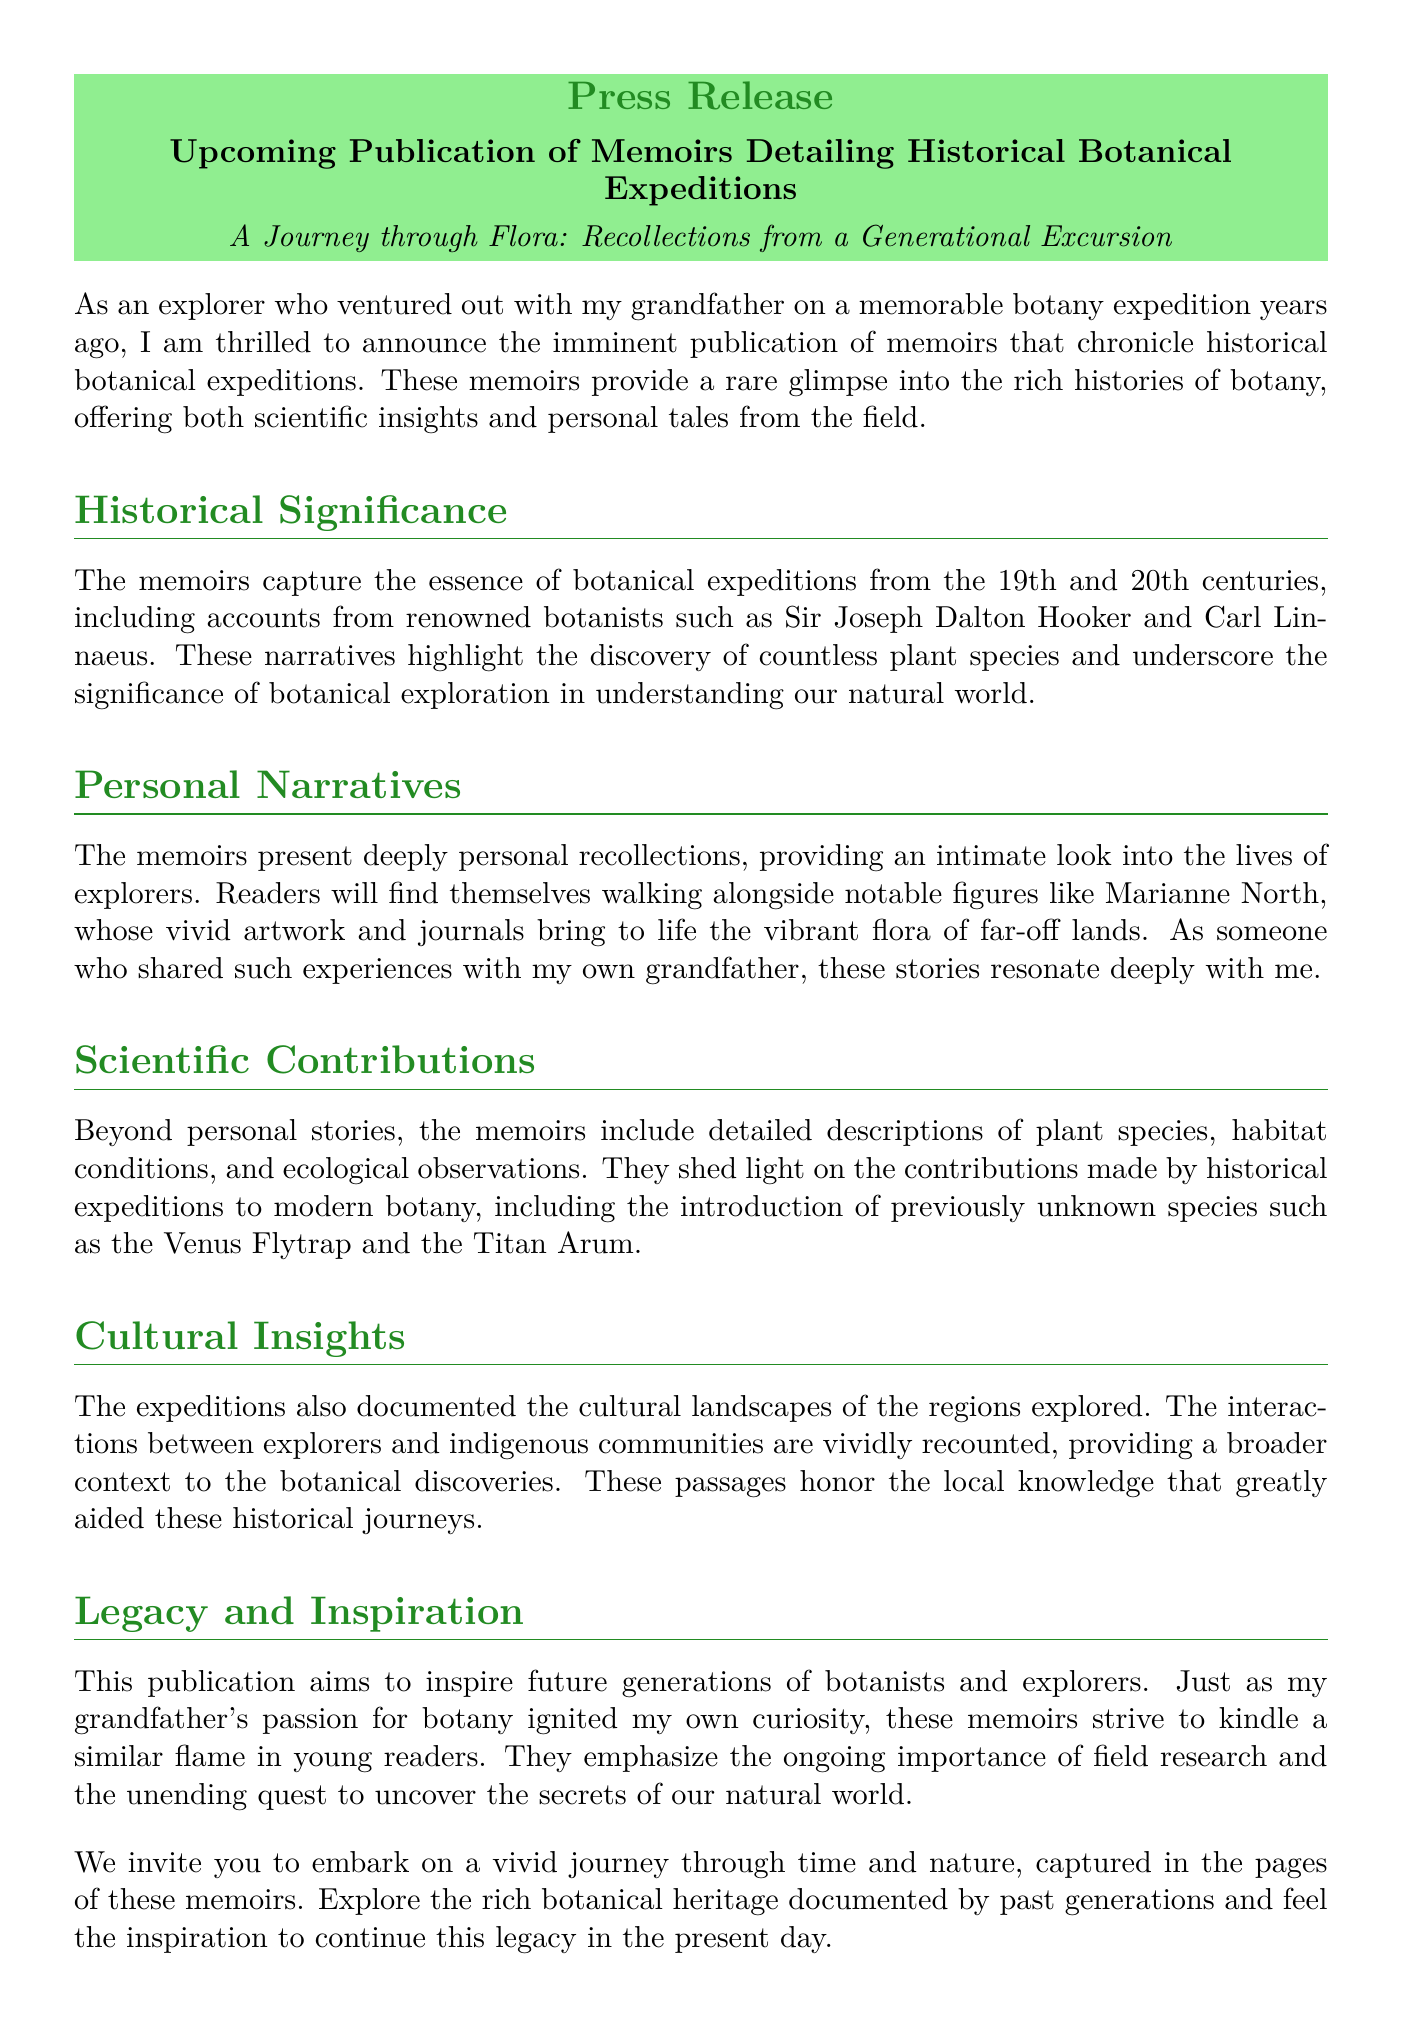What is the publication date of the memoirs? The document states that the memoirs will be available starting December 1, 2023.
Answer: December 1, 2023 Who is the author of the press release? The author's role is indicated in the contact information, which identifies Jane Doe as the Media Relations Specialist.
Answer: Jane Doe What type of illustrations will accompany the exhibition? The document mentions that the exhibition will feature original artifacts and illustrations from these expeditions.
Answer: Original artifacts and illustrations Which renowned botanist is mentioned in the document? The press release highlights accounts from Sir Joseph Dalton Hooker as one of the renowned botanists featured.
Answer: Sir Joseph Dalton Hooker What is the aim of the publication? The press release states that the publication aims to inspire future generations of botanists and explorers.
Answer: To inspire future generations What is the significance of the historical expeditions? The memoirs underscore the significance of botanical exploration in understanding our natural world.
Answer: Understanding our natural world Which plant species is noted in the document for being introduced through these expeditions? The memoirs highlight the introduction of the Venus Flytrap as a significant species discovered.
Answer: Venus Flytrap What do the personal narratives in the memoirs provide? The memoirs present deeply personal recollections of explorers, offering intimate insights into their lives.
Answer: Intimate insights into their lives What kind of insights does the memoir contain about indigenous communities? The document states that interactions between explorers and indigenous communities are vividly recounted.
Answer: Vivid recounting of interactions 